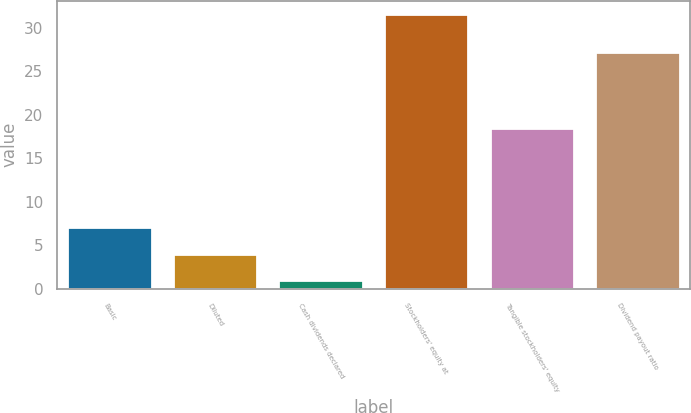<chart> <loc_0><loc_0><loc_500><loc_500><bar_chart><fcel>Basic<fcel>Diluted<fcel>Cash dividends declared<fcel>Stockholders' equity at<fcel>Tangible stockholders' equity<fcel>Dividend payout ratio<nl><fcel>7.1<fcel>4.05<fcel>1<fcel>31.54<fcel>18.54<fcel>27.19<nl></chart> 